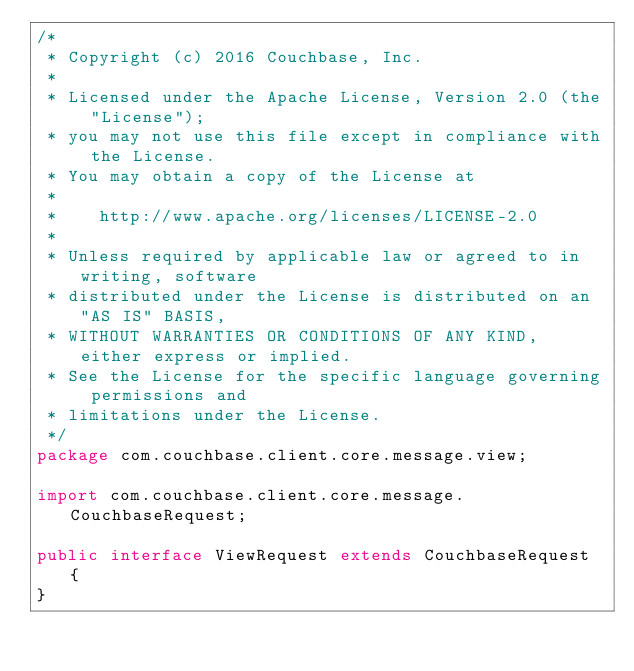Convert code to text. <code><loc_0><loc_0><loc_500><loc_500><_Java_>/*
 * Copyright (c) 2016 Couchbase, Inc.
 *
 * Licensed under the Apache License, Version 2.0 (the "License");
 * you may not use this file except in compliance with the License.
 * You may obtain a copy of the License at
 *
 *    http://www.apache.org/licenses/LICENSE-2.0
 *
 * Unless required by applicable law or agreed to in writing, software
 * distributed under the License is distributed on an "AS IS" BASIS,
 * WITHOUT WARRANTIES OR CONDITIONS OF ANY KIND, either express or implied.
 * See the License for the specific language governing permissions and
 * limitations under the License.
 */
package com.couchbase.client.core.message.view;

import com.couchbase.client.core.message.CouchbaseRequest;

public interface ViewRequest extends CouchbaseRequest {
}
</code> 